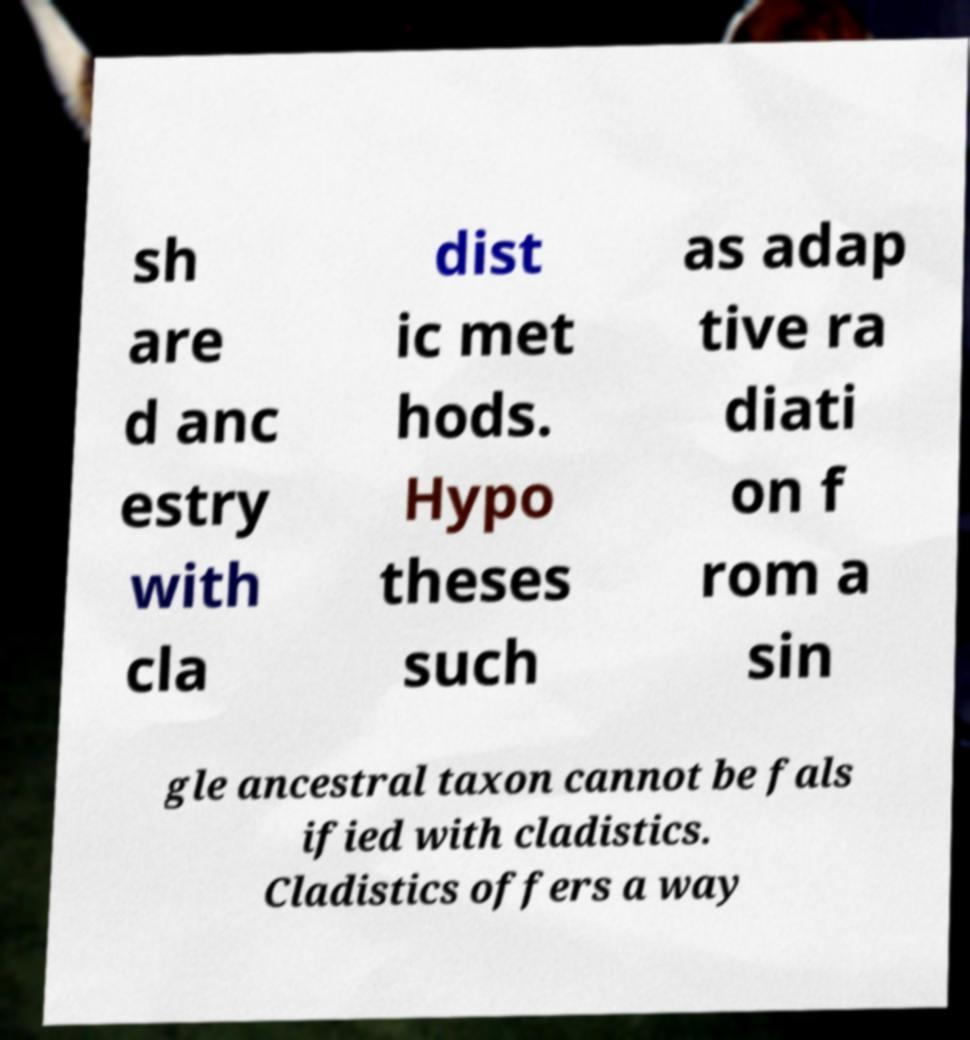Can you accurately transcribe the text from the provided image for me? sh are d anc estry with cla dist ic met hods. Hypo theses such as adap tive ra diati on f rom a sin gle ancestral taxon cannot be fals ified with cladistics. Cladistics offers a way 